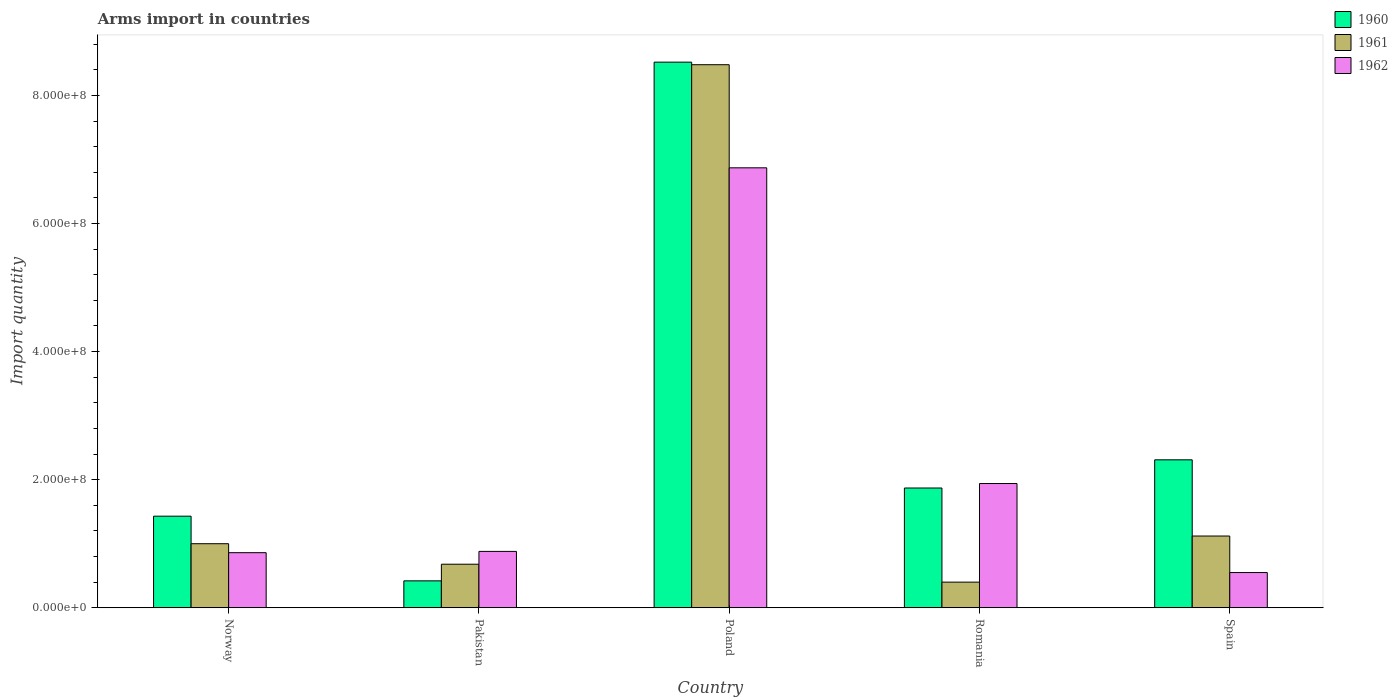Are the number of bars on each tick of the X-axis equal?
Provide a short and direct response. Yes. How many bars are there on the 5th tick from the left?
Provide a short and direct response. 3. How many bars are there on the 1st tick from the right?
Ensure brevity in your answer.  3. What is the label of the 3rd group of bars from the left?
Your answer should be very brief. Poland. In how many cases, is the number of bars for a given country not equal to the number of legend labels?
Provide a succinct answer. 0. What is the total arms import in 1962 in Pakistan?
Give a very brief answer. 8.80e+07. Across all countries, what is the maximum total arms import in 1962?
Your response must be concise. 6.87e+08. Across all countries, what is the minimum total arms import in 1962?
Make the answer very short. 5.50e+07. In which country was the total arms import in 1960 minimum?
Provide a short and direct response. Pakistan. What is the total total arms import in 1962 in the graph?
Your answer should be compact. 1.11e+09. What is the difference between the total arms import in 1962 in Pakistan and that in Spain?
Provide a short and direct response. 3.30e+07. What is the difference between the total arms import in 1962 in Pakistan and the total arms import in 1961 in Romania?
Give a very brief answer. 4.80e+07. What is the average total arms import in 1961 per country?
Provide a short and direct response. 2.34e+08. What is the difference between the total arms import of/in 1962 and total arms import of/in 1960 in Spain?
Keep it short and to the point. -1.76e+08. What is the ratio of the total arms import in 1960 in Pakistan to that in Spain?
Your answer should be compact. 0.18. Is the total arms import in 1960 in Romania less than that in Spain?
Keep it short and to the point. Yes. What is the difference between the highest and the second highest total arms import in 1960?
Keep it short and to the point. 6.65e+08. What is the difference between the highest and the lowest total arms import in 1962?
Provide a short and direct response. 6.32e+08. In how many countries, is the total arms import in 1961 greater than the average total arms import in 1961 taken over all countries?
Offer a terse response. 1. Is the sum of the total arms import in 1961 in Poland and Spain greater than the maximum total arms import in 1962 across all countries?
Keep it short and to the point. Yes. What does the 3rd bar from the left in Romania represents?
Make the answer very short. 1962. What is the difference between two consecutive major ticks on the Y-axis?
Ensure brevity in your answer.  2.00e+08. Does the graph contain any zero values?
Ensure brevity in your answer.  No. Does the graph contain grids?
Offer a very short reply. No. How are the legend labels stacked?
Provide a succinct answer. Vertical. What is the title of the graph?
Keep it short and to the point. Arms import in countries. What is the label or title of the Y-axis?
Keep it short and to the point. Import quantity. What is the Import quantity of 1960 in Norway?
Your answer should be very brief. 1.43e+08. What is the Import quantity in 1962 in Norway?
Make the answer very short. 8.60e+07. What is the Import quantity in 1960 in Pakistan?
Provide a succinct answer. 4.20e+07. What is the Import quantity in 1961 in Pakistan?
Your answer should be very brief. 6.80e+07. What is the Import quantity of 1962 in Pakistan?
Your response must be concise. 8.80e+07. What is the Import quantity of 1960 in Poland?
Make the answer very short. 8.52e+08. What is the Import quantity of 1961 in Poland?
Your answer should be very brief. 8.48e+08. What is the Import quantity in 1962 in Poland?
Ensure brevity in your answer.  6.87e+08. What is the Import quantity of 1960 in Romania?
Your response must be concise. 1.87e+08. What is the Import quantity of 1961 in Romania?
Provide a short and direct response. 4.00e+07. What is the Import quantity of 1962 in Romania?
Give a very brief answer. 1.94e+08. What is the Import quantity of 1960 in Spain?
Give a very brief answer. 2.31e+08. What is the Import quantity of 1961 in Spain?
Offer a very short reply. 1.12e+08. What is the Import quantity of 1962 in Spain?
Offer a very short reply. 5.50e+07. Across all countries, what is the maximum Import quantity in 1960?
Make the answer very short. 8.52e+08. Across all countries, what is the maximum Import quantity in 1961?
Offer a very short reply. 8.48e+08. Across all countries, what is the maximum Import quantity in 1962?
Offer a terse response. 6.87e+08. Across all countries, what is the minimum Import quantity in 1960?
Ensure brevity in your answer.  4.20e+07. Across all countries, what is the minimum Import quantity in 1961?
Keep it short and to the point. 4.00e+07. Across all countries, what is the minimum Import quantity in 1962?
Offer a very short reply. 5.50e+07. What is the total Import quantity in 1960 in the graph?
Your answer should be compact. 1.46e+09. What is the total Import quantity in 1961 in the graph?
Provide a short and direct response. 1.17e+09. What is the total Import quantity in 1962 in the graph?
Make the answer very short. 1.11e+09. What is the difference between the Import quantity of 1960 in Norway and that in Pakistan?
Offer a terse response. 1.01e+08. What is the difference between the Import quantity in 1961 in Norway and that in Pakistan?
Offer a terse response. 3.20e+07. What is the difference between the Import quantity of 1960 in Norway and that in Poland?
Your response must be concise. -7.09e+08. What is the difference between the Import quantity in 1961 in Norway and that in Poland?
Ensure brevity in your answer.  -7.48e+08. What is the difference between the Import quantity of 1962 in Norway and that in Poland?
Keep it short and to the point. -6.01e+08. What is the difference between the Import quantity in 1960 in Norway and that in Romania?
Keep it short and to the point. -4.40e+07. What is the difference between the Import quantity in 1961 in Norway and that in Romania?
Make the answer very short. 6.00e+07. What is the difference between the Import quantity in 1962 in Norway and that in Romania?
Ensure brevity in your answer.  -1.08e+08. What is the difference between the Import quantity of 1960 in Norway and that in Spain?
Make the answer very short. -8.80e+07. What is the difference between the Import quantity in 1961 in Norway and that in Spain?
Offer a very short reply. -1.20e+07. What is the difference between the Import quantity of 1962 in Norway and that in Spain?
Your answer should be very brief. 3.10e+07. What is the difference between the Import quantity in 1960 in Pakistan and that in Poland?
Provide a short and direct response. -8.10e+08. What is the difference between the Import quantity in 1961 in Pakistan and that in Poland?
Offer a very short reply. -7.80e+08. What is the difference between the Import quantity of 1962 in Pakistan and that in Poland?
Your answer should be very brief. -5.99e+08. What is the difference between the Import quantity of 1960 in Pakistan and that in Romania?
Your answer should be compact. -1.45e+08. What is the difference between the Import quantity in 1961 in Pakistan and that in Romania?
Provide a short and direct response. 2.80e+07. What is the difference between the Import quantity in 1962 in Pakistan and that in Romania?
Offer a terse response. -1.06e+08. What is the difference between the Import quantity of 1960 in Pakistan and that in Spain?
Your response must be concise. -1.89e+08. What is the difference between the Import quantity of 1961 in Pakistan and that in Spain?
Keep it short and to the point. -4.40e+07. What is the difference between the Import quantity of 1962 in Pakistan and that in Spain?
Make the answer very short. 3.30e+07. What is the difference between the Import quantity of 1960 in Poland and that in Romania?
Your answer should be compact. 6.65e+08. What is the difference between the Import quantity in 1961 in Poland and that in Romania?
Keep it short and to the point. 8.08e+08. What is the difference between the Import quantity of 1962 in Poland and that in Romania?
Offer a terse response. 4.93e+08. What is the difference between the Import quantity in 1960 in Poland and that in Spain?
Ensure brevity in your answer.  6.21e+08. What is the difference between the Import quantity of 1961 in Poland and that in Spain?
Ensure brevity in your answer.  7.36e+08. What is the difference between the Import quantity of 1962 in Poland and that in Spain?
Give a very brief answer. 6.32e+08. What is the difference between the Import quantity in 1960 in Romania and that in Spain?
Your answer should be compact. -4.40e+07. What is the difference between the Import quantity of 1961 in Romania and that in Spain?
Your response must be concise. -7.20e+07. What is the difference between the Import quantity in 1962 in Romania and that in Spain?
Keep it short and to the point. 1.39e+08. What is the difference between the Import quantity of 1960 in Norway and the Import quantity of 1961 in Pakistan?
Offer a very short reply. 7.50e+07. What is the difference between the Import quantity of 1960 in Norway and the Import quantity of 1962 in Pakistan?
Make the answer very short. 5.50e+07. What is the difference between the Import quantity of 1961 in Norway and the Import quantity of 1962 in Pakistan?
Your response must be concise. 1.20e+07. What is the difference between the Import quantity in 1960 in Norway and the Import quantity in 1961 in Poland?
Provide a short and direct response. -7.05e+08. What is the difference between the Import quantity of 1960 in Norway and the Import quantity of 1962 in Poland?
Make the answer very short. -5.44e+08. What is the difference between the Import quantity in 1961 in Norway and the Import quantity in 1962 in Poland?
Make the answer very short. -5.87e+08. What is the difference between the Import quantity in 1960 in Norway and the Import quantity in 1961 in Romania?
Your answer should be compact. 1.03e+08. What is the difference between the Import quantity of 1960 in Norway and the Import quantity of 1962 in Romania?
Provide a succinct answer. -5.10e+07. What is the difference between the Import quantity in 1961 in Norway and the Import quantity in 1962 in Romania?
Offer a very short reply. -9.40e+07. What is the difference between the Import quantity in 1960 in Norway and the Import quantity in 1961 in Spain?
Offer a very short reply. 3.10e+07. What is the difference between the Import quantity in 1960 in Norway and the Import quantity in 1962 in Spain?
Your answer should be compact. 8.80e+07. What is the difference between the Import quantity in 1961 in Norway and the Import quantity in 1962 in Spain?
Provide a short and direct response. 4.50e+07. What is the difference between the Import quantity in 1960 in Pakistan and the Import quantity in 1961 in Poland?
Your answer should be very brief. -8.06e+08. What is the difference between the Import quantity in 1960 in Pakistan and the Import quantity in 1962 in Poland?
Offer a terse response. -6.45e+08. What is the difference between the Import quantity of 1961 in Pakistan and the Import quantity of 1962 in Poland?
Provide a succinct answer. -6.19e+08. What is the difference between the Import quantity of 1960 in Pakistan and the Import quantity of 1961 in Romania?
Your response must be concise. 2.00e+06. What is the difference between the Import quantity of 1960 in Pakistan and the Import quantity of 1962 in Romania?
Offer a terse response. -1.52e+08. What is the difference between the Import quantity of 1961 in Pakistan and the Import quantity of 1962 in Romania?
Provide a short and direct response. -1.26e+08. What is the difference between the Import quantity in 1960 in Pakistan and the Import quantity in 1961 in Spain?
Offer a terse response. -7.00e+07. What is the difference between the Import quantity in 1960 in Pakistan and the Import quantity in 1962 in Spain?
Your answer should be compact. -1.30e+07. What is the difference between the Import quantity in 1961 in Pakistan and the Import quantity in 1962 in Spain?
Provide a short and direct response. 1.30e+07. What is the difference between the Import quantity of 1960 in Poland and the Import quantity of 1961 in Romania?
Ensure brevity in your answer.  8.12e+08. What is the difference between the Import quantity in 1960 in Poland and the Import quantity in 1962 in Romania?
Provide a succinct answer. 6.58e+08. What is the difference between the Import quantity of 1961 in Poland and the Import quantity of 1962 in Romania?
Ensure brevity in your answer.  6.54e+08. What is the difference between the Import quantity in 1960 in Poland and the Import quantity in 1961 in Spain?
Provide a succinct answer. 7.40e+08. What is the difference between the Import quantity in 1960 in Poland and the Import quantity in 1962 in Spain?
Your response must be concise. 7.97e+08. What is the difference between the Import quantity of 1961 in Poland and the Import quantity of 1962 in Spain?
Ensure brevity in your answer.  7.93e+08. What is the difference between the Import quantity of 1960 in Romania and the Import quantity of 1961 in Spain?
Keep it short and to the point. 7.50e+07. What is the difference between the Import quantity of 1960 in Romania and the Import quantity of 1962 in Spain?
Give a very brief answer. 1.32e+08. What is the difference between the Import quantity of 1961 in Romania and the Import quantity of 1962 in Spain?
Provide a short and direct response. -1.50e+07. What is the average Import quantity in 1960 per country?
Keep it short and to the point. 2.91e+08. What is the average Import quantity in 1961 per country?
Make the answer very short. 2.34e+08. What is the average Import quantity in 1962 per country?
Make the answer very short. 2.22e+08. What is the difference between the Import quantity in 1960 and Import quantity in 1961 in Norway?
Your answer should be compact. 4.30e+07. What is the difference between the Import quantity in 1960 and Import quantity in 1962 in Norway?
Offer a terse response. 5.70e+07. What is the difference between the Import quantity of 1961 and Import quantity of 1962 in Norway?
Make the answer very short. 1.40e+07. What is the difference between the Import quantity of 1960 and Import quantity of 1961 in Pakistan?
Your answer should be very brief. -2.60e+07. What is the difference between the Import quantity in 1960 and Import quantity in 1962 in Pakistan?
Your answer should be compact. -4.60e+07. What is the difference between the Import quantity in 1961 and Import quantity in 1962 in Pakistan?
Offer a terse response. -2.00e+07. What is the difference between the Import quantity in 1960 and Import quantity in 1961 in Poland?
Provide a short and direct response. 4.00e+06. What is the difference between the Import quantity of 1960 and Import quantity of 1962 in Poland?
Give a very brief answer. 1.65e+08. What is the difference between the Import quantity in 1961 and Import quantity in 1962 in Poland?
Provide a short and direct response. 1.61e+08. What is the difference between the Import quantity of 1960 and Import quantity of 1961 in Romania?
Your response must be concise. 1.47e+08. What is the difference between the Import quantity in 1960 and Import quantity in 1962 in Romania?
Make the answer very short. -7.00e+06. What is the difference between the Import quantity of 1961 and Import quantity of 1962 in Romania?
Keep it short and to the point. -1.54e+08. What is the difference between the Import quantity of 1960 and Import quantity of 1961 in Spain?
Your response must be concise. 1.19e+08. What is the difference between the Import quantity of 1960 and Import quantity of 1962 in Spain?
Give a very brief answer. 1.76e+08. What is the difference between the Import quantity of 1961 and Import quantity of 1962 in Spain?
Offer a terse response. 5.70e+07. What is the ratio of the Import quantity of 1960 in Norway to that in Pakistan?
Provide a succinct answer. 3.4. What is the ratio of the Import quantity in 1961 in Norway to that in Pakistan?
Your answer should be compact. 1.47. What is the ratio of the Import quantity in 1962 in Norway to that in Pakistan?
Your answer should be very brief. 0.98. What is the ratio of the Import quantity of 1960 in Norway to that in Poland?
Offer a very short reply. 0.17. What is the ratio of the Import quantity in 1961 in Norway to that in Poland?
Your answer should be very brief. 0.12. What is the ratio of the Import quantity of 1962 in Norway to that in Poland?
Ensure brevity in your answer.  0.13. What is the ratio of the Import quantity in 1960 in Norway to that in Romania?
Give a very brief answer. 0.76. What is the ratio of the Import quantity in 1961 in Norway to that in Romania?
Offer a terse response. 2.5. What is the ratio of the Import quantity in 1962 in Norway to that in Romania?
Keep it short and to the point. 0.44. What is the ratio of the Import quantity of 1960 in Norway to that in Spain?
Give a very brief answer. 0.62. What is the ratio of the Import quantity in 1961 in Norway to that in Spain?
Offer a terse response. 0.89. What is the ratio of the Import quantity of 1962 in Norway to that in Spain?
Make the answer very short. 1.56. What is the ratio of the Import quantity in 1960 in Pakistan to that in Poland?
Your response must be concise. 0.05. What is the ratio of the Import quantity in 1961 in Pakistan to that in Poland?
Keep it short and to the point. 0.08. What is the ratio of the Import quantity in 1962 in Pakistan to that in Poland?
Your answer should be compact. 0.13. What is the ratio of the Import quantity in 1960 in Pakistan to that in Romania?
Offer a terse response. 0.22. What is the ratio of the Import quantity of 1961 in Pakistan to that in Romania?
Provide a short and direct response. 1.7. What is the ratio of the Import quantity of 1962 in Pakistan to that in Romania?
Offer a very short reply. 0.45. What is the ratio of the Import quantity in 1960 in Pakistan to that in Spain?
Your answer should be very brief. 0.18. What is the ratio of the Import quantity in 1961 in Pakistan to that in Spain?
Offer a terse response. 0.61. What is the ratio of the Import quantity of 1962 in Pakistan to that in Spain?
Offer a terse response. 1.6. What is the ratio of the Import quantity in 1960 in Poland to that in Romania?
Provide a succinct answer. 4.56. What is the ratio of the Import quantity of 1961 in Poland to that in Romania?
Provide a short and direct response. 21.2. What is the ratio of the Import quantity in 1962 in Poland to that in Romania?
Offer a very short reply. 3.54. What is the ratio of the Import quantity in 1960 in Poland to that in Spain?
Your answer should be very brief. 3.69. What is the ratio of the Import quantity in 1961 in Poland to that in Spain?
Your answer should be very brief. 7.57. What is the ratio of the Import quantity in 1962 in Poland to that in Spain?
Give a very brief answer. 12.49. What is the ratio of the Import quantity in 1960 in Romania to that in Spain?
Ensure brevity in your answer.  0.81. What is the ratio of the Import quantity in 1961 in Romania to that in Spain?
Offer a very short reply. 0.36. What is the ratio of the Import quantity in 1962 in Romania to that in Spain?
Provide a short and direct response. 3.53. What is the difference between the highest and the second highest Import quantity of 1960?
Offer a terse response. 6.21e+08. What is the difference between the highest and the second highest Import quantity of 1961?
Ensure brevity in your answer.  7.36e+08. What is the difference between the highest and the second highest Import quantity of 1962?
Make the answer very short. 4.93e+08. What is the difference between the highest and the lowest Import quantity in 1960?
Your answer should be very brief. 8.10e+08. What is the difference between the highest and the lowest Import quantity in 1961?
Your answer should be very brief. 8.08e+08. What is the difference between the highest and the lowest Import quantity of 1962?
Make the answer very short. 6.32e+08. 